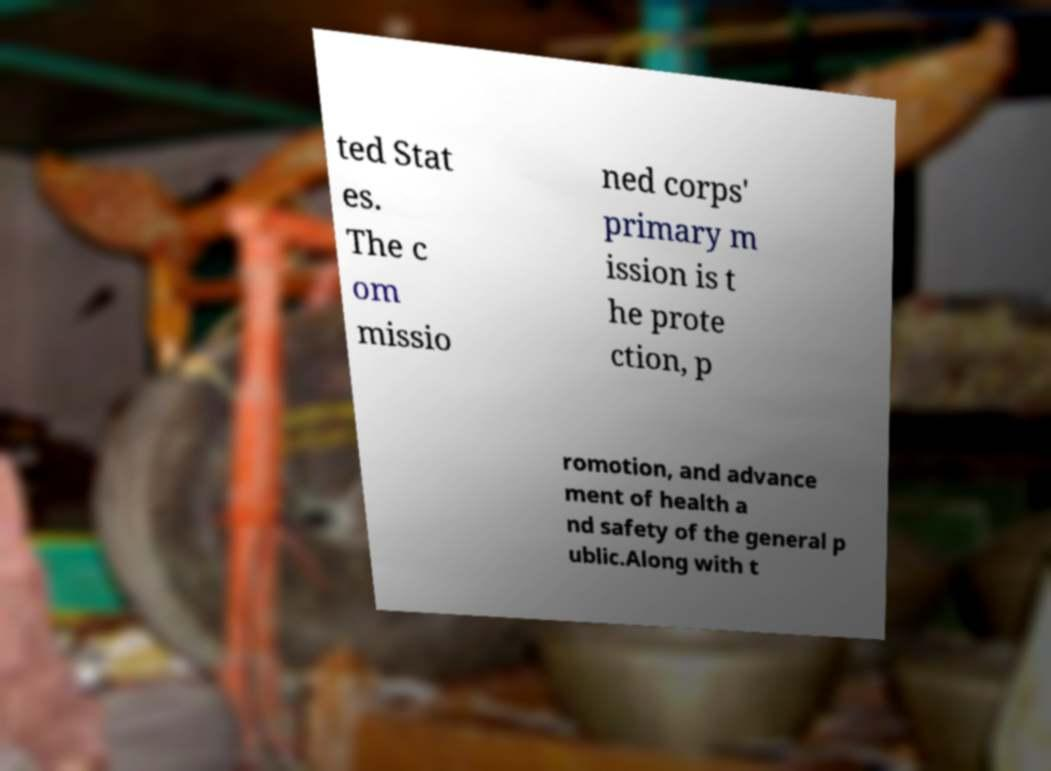Please identify and transcribe the text found in this image. ted Stat es. The c om missio ned corps' primary m ission is t he prote ction, p romotion, and advance ment of health a nd safety of the general p ublic.Along with t 